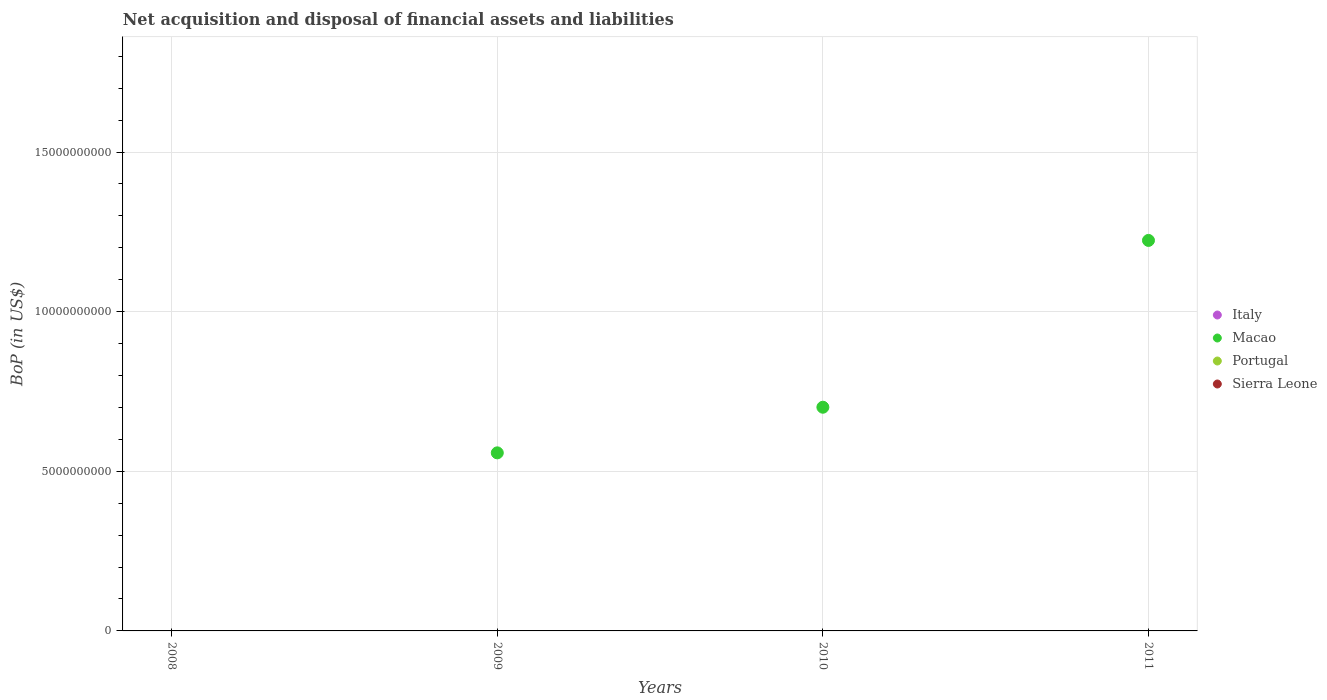How many different coloured dotlines are there?
Your answer should be very brief. 1. What is the Balance of Payments in Macao in 2010?
Provide a succinct answer. 7.01e+09. Across all years, what is the minimum Balance of Payments in Macao?
Offer a terse response. 0. In which year was the Balance of Payments in Macao maximum?
Keep it short and to the point. 2011. What is the difference between the Balance of Payments in Macao in 2009 and that in 2010?
Ensure brevity in your answer.  -1.43e+09. What is the average Balance of Payments in Italy per year?
Your response must be concise. 0. What is the difference between the highest and the second highest Balance of Payments in Macao?
Keep it short and to the point. 5.23e+09. In how many years, is the Balance of Payments in Sierra Leone greater than the average Balance of Payments in Sierra Leone taken over all years?
Offer a terse response. 0. Is it the case that in every year, the sum of the Balance of Payments in Macao and Balance of Payments in Portugal  is greater than the sum of Balance of Payments in Italy and Balance of Payments in Sierra Leone?
Ensure brevity in your answer.  No. Is it the case that in every year, the sum of the Balance of Payments in Italy and Balance of Payments in Portugal  is greater than the Balance of Payments in Macao?
Give a very brief answer. No. Is the Balance of Payments in Macao strictly less than the Balance of Payments in Italy over the years?
Your answer should be very brief. No. How many dotlines are there?
Make the answer very short. 1. How many years are there in the graph?
Keep it short and to the point. 4. Does the graph contain grids?
Your answer should be compact. Yes. What is the title of the graph?
Provide a short and direct response. Net acquisition and disposal of financial assets and liabilities. What is the label or title of the Y-axis?
Your answer should be very brief. BoP (in US$). What is the BoP (in US$) of Sierra Leone in 2008?
Your answer should be compact. 0. What is the BoP (in US$) of Macao in 2009?
Provide a succinct answer. 5.58e+09. What is the BoP (in US$) of Macao in 2010?
Provide a short and direct response. 7.01e+09. What is the BoP (in US$) in Italy in 2011?
Provide a succinct answer. 0. What is the BoP (in US$) of Macao in 2011?
Your answer should be very brief. 1.22e+1. What is the BoP (in US$) in Sierra Leone in 2011?
Give a very brief answer. 0. Across all years, what is the maximum BoP (in US$) in Macao?
Keep it short and to the point. 1.22e+1. Across all years, what is the minimum BoP (in US$) in Macao?
Keep it short and to the point. 0. What is the total BoP (in US$) of Macao in the graph?
Offer a terse response. 2.48e+1. What is the total BoP (in US$) in Portugal in the graph?
Your response must be concise. 0. What is the total BoP (in US$) in Sierra Leone in the graph?
Your answer should be very brief. 0. What is the difference between the BoP (in US$) of Macao in 2009 and that in 2010?
Offer a terse response. -1.43e+09. What is the difference between the BoP (in US$) of Macao in 2009 and that in 2011?
Keep it short and to the point. -6.65e+09. What is the difference between the BoP (in US$) of Macao in 2010 and that in 2011?
Make the answer very short. -5.23e+09. What is the average BoP (in US$) in Italy per year?
Ensure brevity in your answer.  0. What is the average BoP (in US$) of Macao per year?
Your answer should be very brief. 6.20e+09. What is the average BoP (in US$) of Portugal per year?
Make the answer very short. 0. What is the average BoP (in US$) of Sierra Leone per year?
Ensure brevity in your answer.  0. What is the ratio of the BoP (in US$) in Macao in 2009 to that in 2010?
Provide a short and direct response. 0.8. What is the ratio of the BoP (in US$) in Macao in 2009 to that in 2011?
Make the answer very short. 0.46. What is the ratio of the BoP (in US$) in Macao in 2010 to that in 2011?
Offer a terse response. 0.57. What is the difference between the highest and the second highest BoP (in US$) in Macao?
Your answer should be very brief. 5.23e+09. What is the difference between the highest and the lowest BoP (in US$) of Macao?
Your response must be concise. 1.22e+1. 